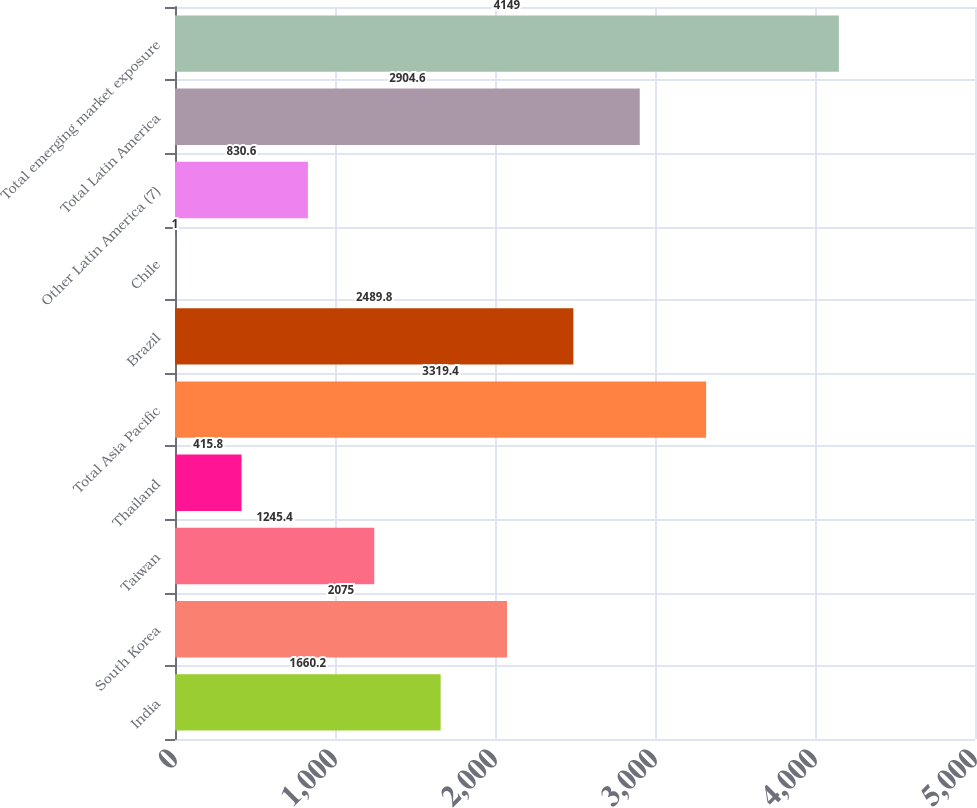Convert chart. <chart><loc_0><loc_0><loc_500><loc_500><bar_chart><fcel>India<fcel>South Korea<fcel>Taiwan<fcel>Thailand<fcel>Total Asia Pacific<fcel>Brazil<fcel>Chile<fcel>Other Latin America (7)<fcel>Total Latin America<fcel>Total emerging market exposure<nl><fcel>1660.2<fcel>2075<fcel>1245.4<fcel>415.8<fcel>3319.4<fcel>2489.8<fcel>1<fcel>830.6<fcel>2904.6<fcel>4149<nl></chart> 